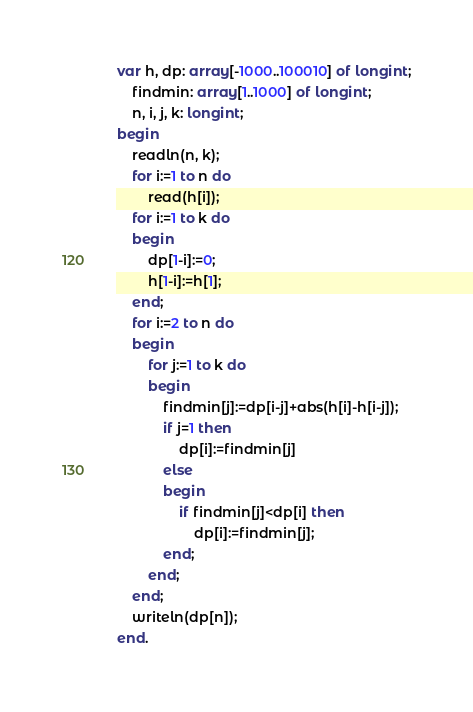Convert code to text. <code><loc_0><loc_0><loc_500><loc_500><_Pascal_>var h, dp: array[-1000..100010] of longint;
    findmin: array[1..1000] of longint;
    n, i, j, k: longint;
begin
    readln(n, k);
    for i:=1 to n do
        read(h[i]);
    for i:=1 to k do
    begin
        dp[1-i]:=0;
        h[1-i]:=h[1];
    end;
    for i:=2 to n do
    begin
        for j:=1 to k do
        begin
            findmin[j]:=dp[i-j]+abs(h[i]-h[i-j]);
            if j=1 then
                dp[i]:=findmin[j]
            else
            begin
                if findmin[j]<dp[i] then
                    dp[i]:=findmin[j];
            end;
        end;
    end;
    writeln(dp[n]);
end.</code> 